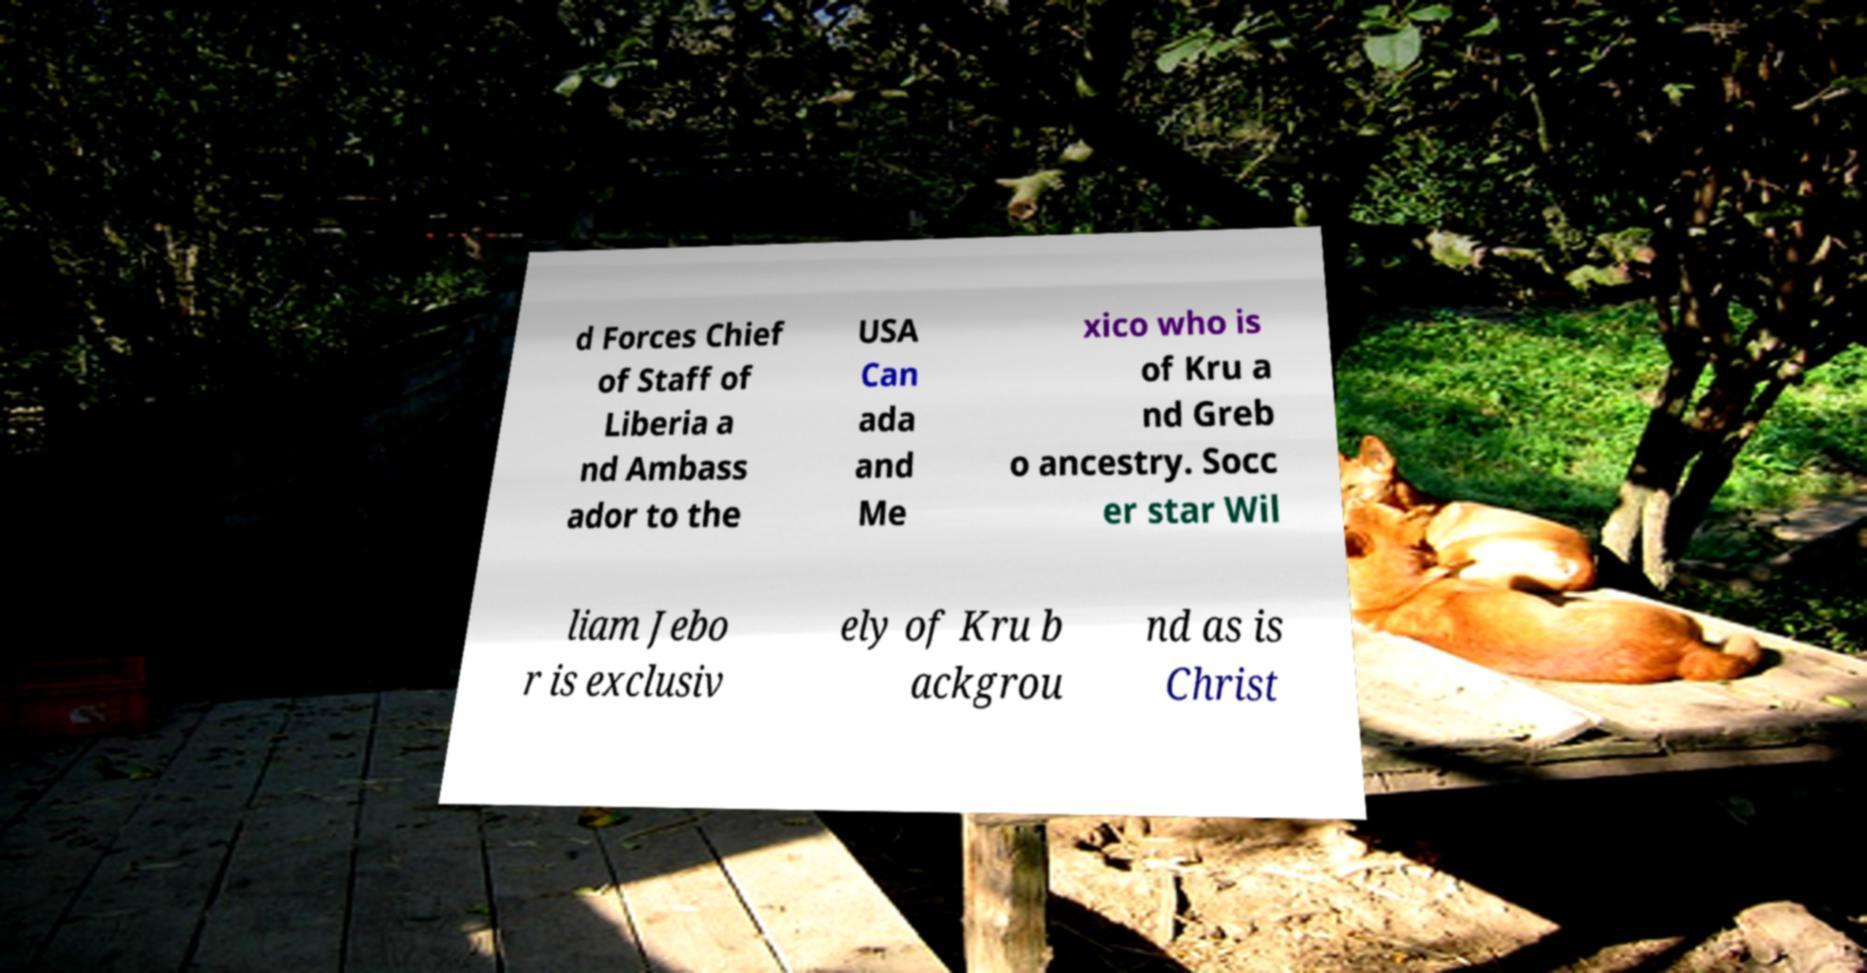Can you read and provide the text displayed in the image?This photo seems to have some interesting text. Can you extract and type it out for me? d Forces Chief of Staff of Liberia a nd Ambass ador to the USA Can ada and Me xico who is of Kru a nd Greb o ancestry. Socc er star Wil liam Jebo r is exclusiv ely of Kru b ackgrou nd as is Christ 